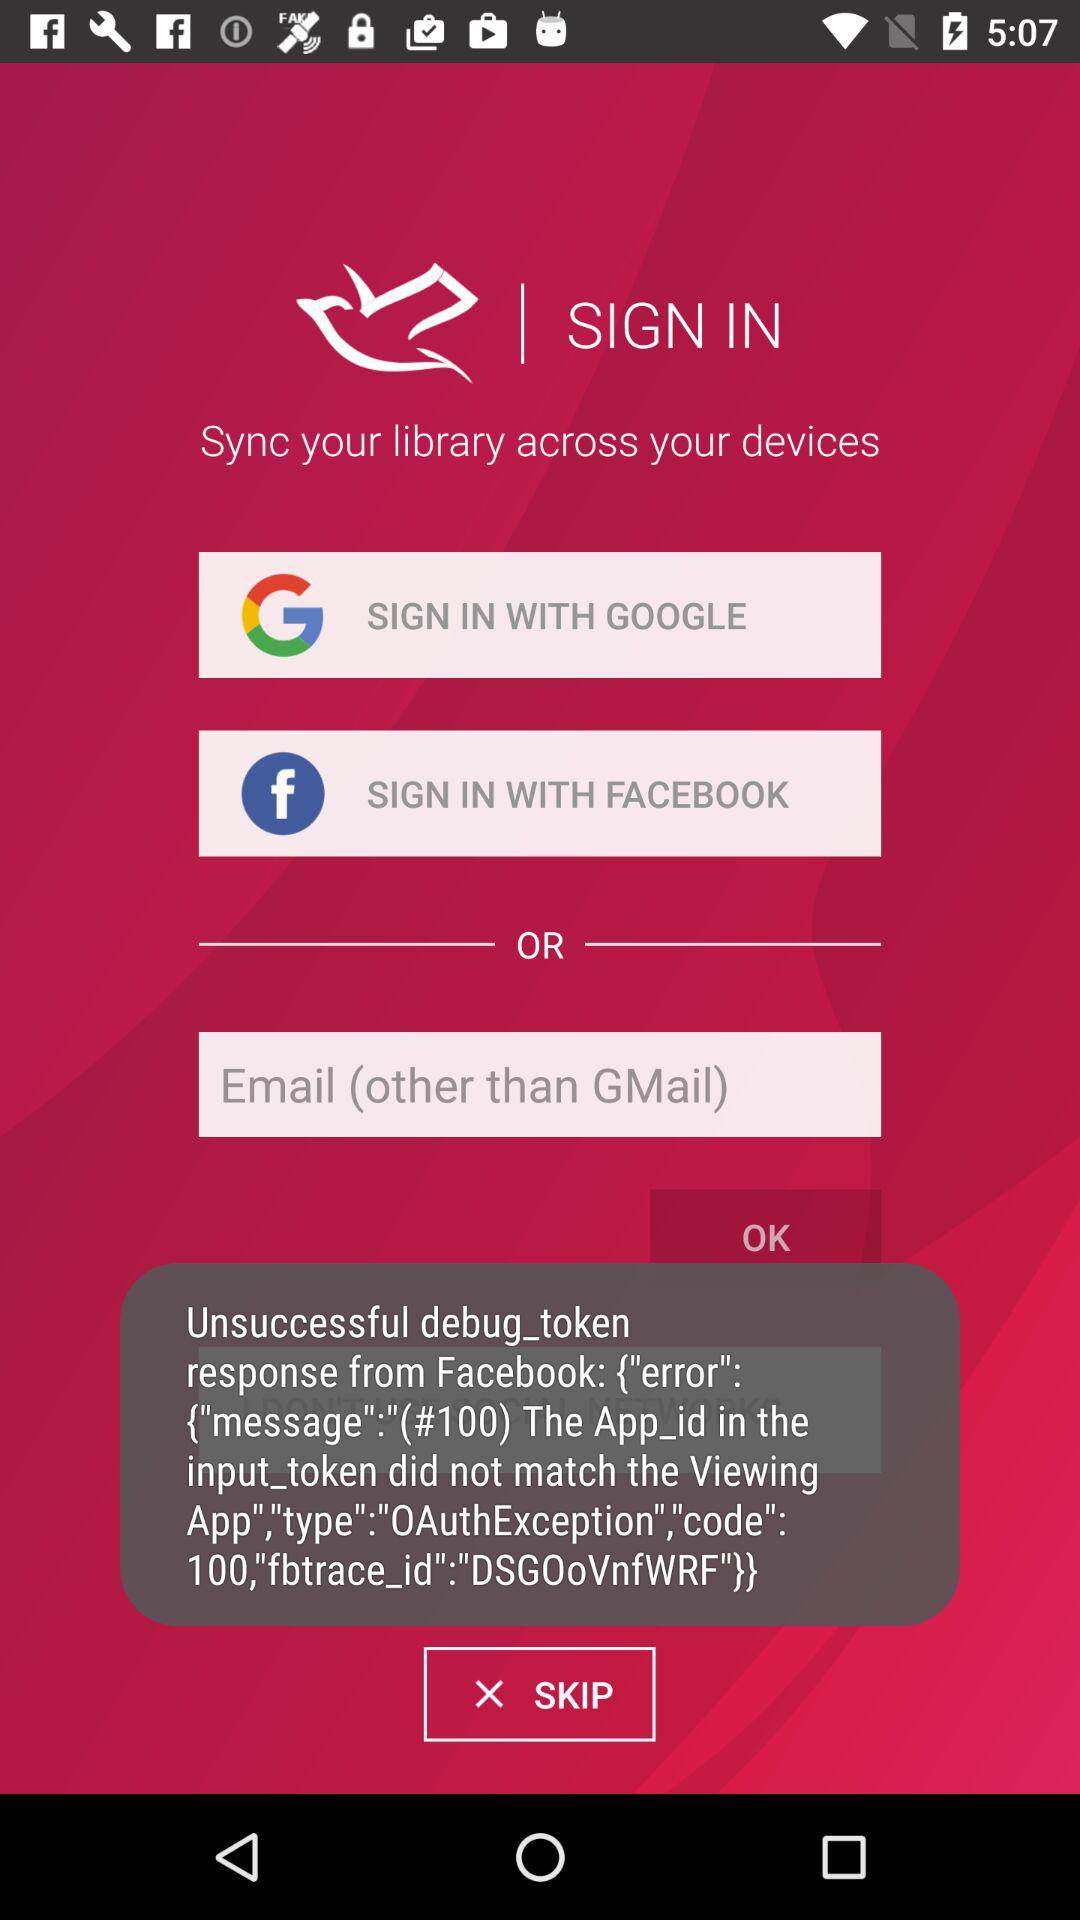What application can we use to sign in? You can use "GOOGLE" and "FACEBOOK". 